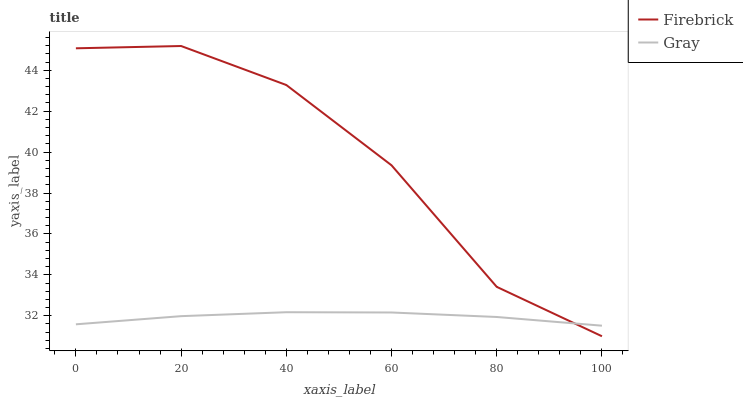Does Gray have the minimum area under the curve?
Answer yes or no. Yes. Does Firebrick have the maximum area under the curve?
Answer yes or no. Yes. Does Firebrick have the minimum area under the curve?
Answer yes or no. No. Is Gray the smoothest?
Answer yes or no. Yes. Is Firebrick the roughest?
Answer yes or no. Yes. Is Firebrick the smoothest?
Answer yes or no. No. Does Firebrick have the lowest value?
Answer yes or no. Yes. Does Firebrick have the highest value?
Answer yes or no. Yes. Does Gray intersect Firebrick?
Answer yes or no. Yes. Is Gray less than Firebrick?
Answer yes or no. No. Is Gray greater than Firebrick?
Answer yes or no. No. 